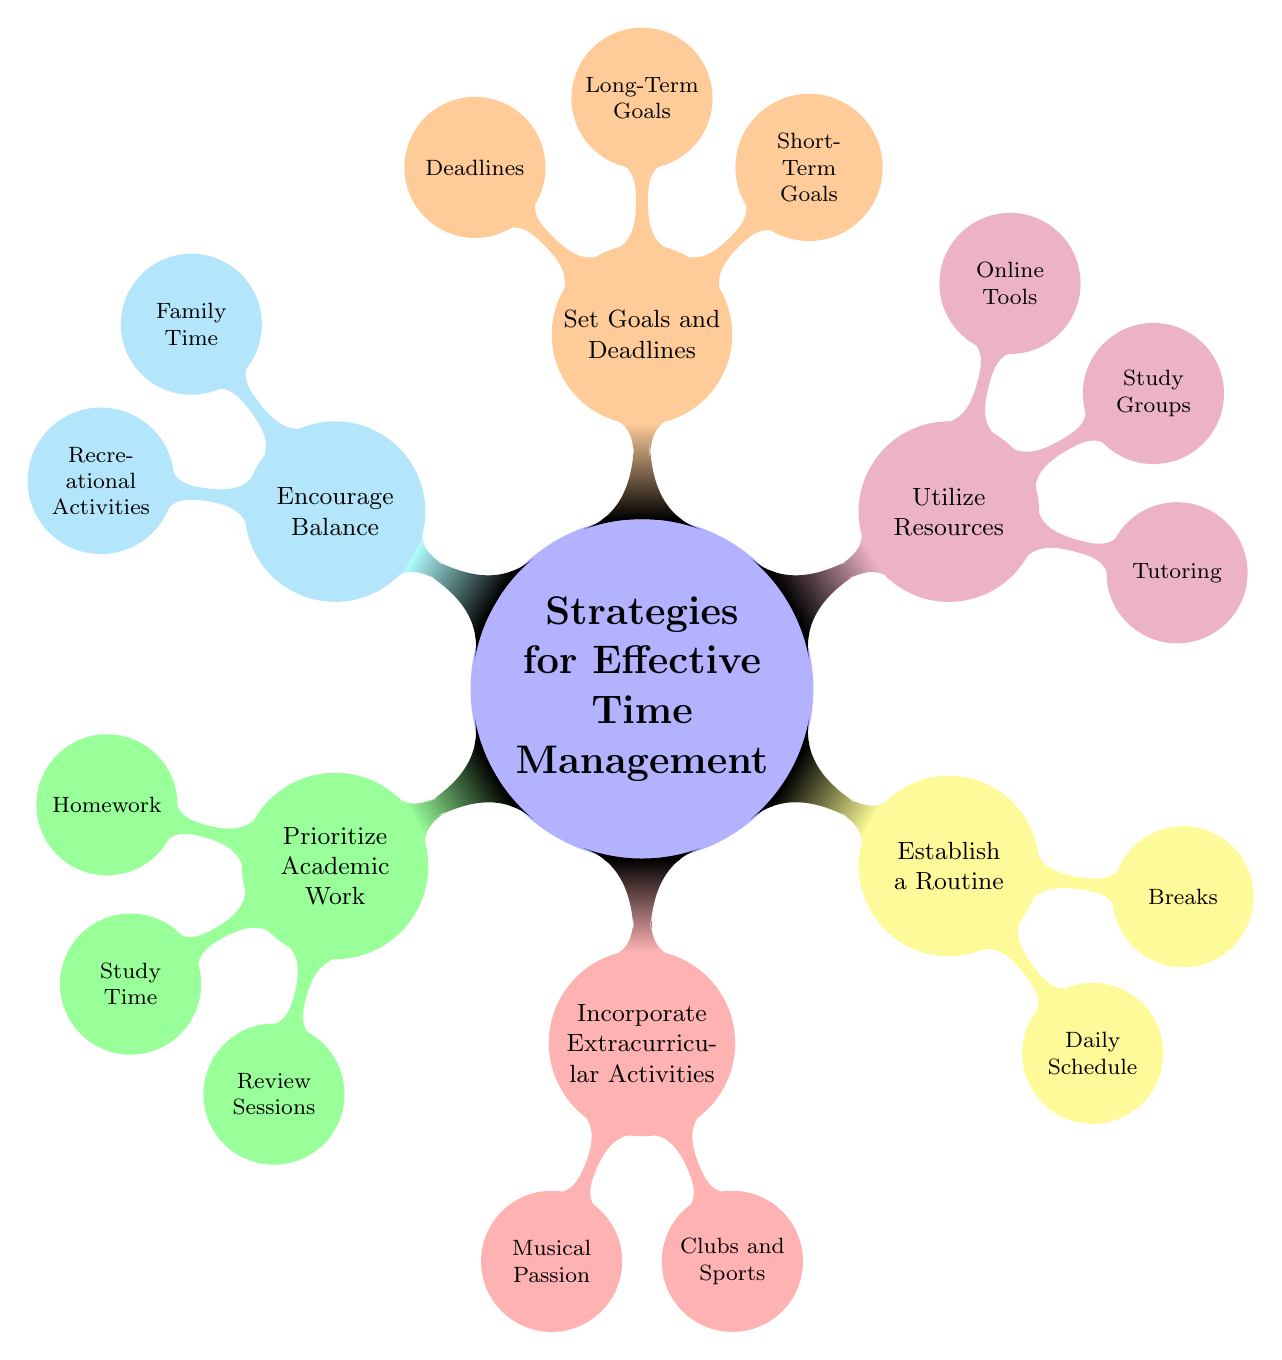What are the main strategies for effective time management? The main strategies are located at the first level of the mind map, branching out from the central node, which include Prioritize Academic Work, Incorporate Extracurricular Activities, Establish a Routine, Utilize Resources, Set Goals and Deadlines, and Encourage Balance.
Answer: Prioritize Academic Work, Incorporate Extracurricular Activities, Establish a Routine, Utilize Resources, Set Goals and Deadlines, Encourage Balance How many nodes are there in the 'Utilize Resources' category? In the 'Utilize Resources' category, there are three nodes: Tutoring, Study Groups, and Online Tools. Counting these gives us a total of three nodes.
Answer: 3 What type of activities fall under 'Incorporate Extracurricular Activities'? Under this category, we see two specific activities listed: Musical Passion and Clubs and Sports. These represent the ways to engage in extracurriculars.
Answer: Musical Passion, Clubs and Sports Which strategy focuses on maintaining family connections? The strategy that directly addresses maintaining family connections is 'Encourage Balance', specifically through the node Family Time, which emphasizes dinner time discussions about school and progress.
Answer: Encourage Balance What kind of goals are indicated in the 'Set Goals and Deadlines' section? The section 'Set Goals and Deadlines' identifies short-term goals like achieving an A in an upcoming math test, and long-term goals such as maintaining a high GPA throughout the semester. This segment outlines both immediate and overarching aspirations.
Answer: Short-Term Goals, Long-Term Goals Why is establishing a routine important for students? Establishing a routine is important as highlighted in the mind map under the category 'Establish a Routine'. It emphasizes the importance of having a Daily Schedule and taking Breaks, which helps students manage their time effectively and maintain balance.
Answer: Daily Schedule, Breaks What resources can be utilized for academic support according to the diagram? The diagram lists three resources for academic support under 'Utilize Resources': Tutoring, Study Groups, and Online Tools. These resources are essential in assisting students with their studies.
Answer: Tutoring, Study Groups, Online Tools How does the mind map suggest students should approach their homework? The mind map indicates that under 'Prioritize Academic Work', students should focus on Homework by managing daily mathematics and science assignments, which suggests a structured approach to handling homework effectively.
Answer: Daily mathematics and science assignments In what ways does the mind map suggest students should manage their study time? Under 'Prioritize Academic Work', the section on Study Time suggests students should allocate specific hours for subjects with upcoming exams, thus highlighting the importance of planning study periods well in advance.
Answer: Dedicated hours for subjects with upcoming exams 